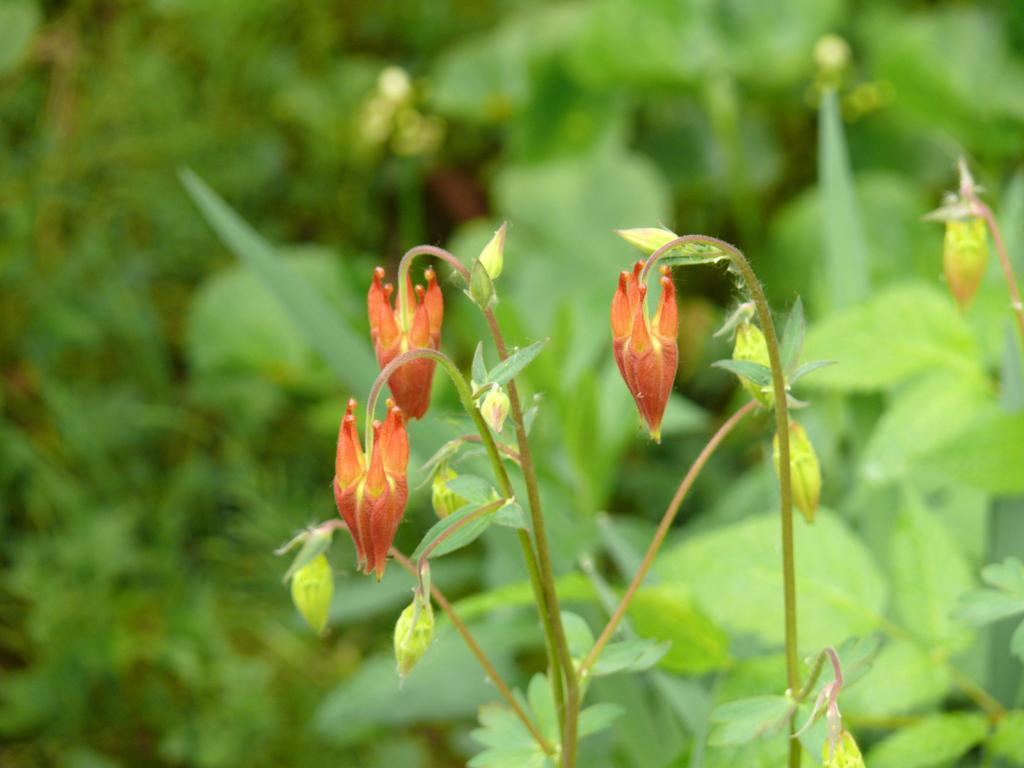What type of living organisms can be seen in the image? Plants can be seen in the image. What specific parts of the plants are visible in the foreground? In the foreground, there are leaves, flowers, and buds on the stems. Can you describe the background of the image? The background of the image is blurry. How many legs can be seen on the plant in the image? Plants do not have legs, so there are no legs visible in the image. What type of egg is being used to fertilize the plants in the image? There are no eggs present in the image, as plants do not require eggs for fertilization. 